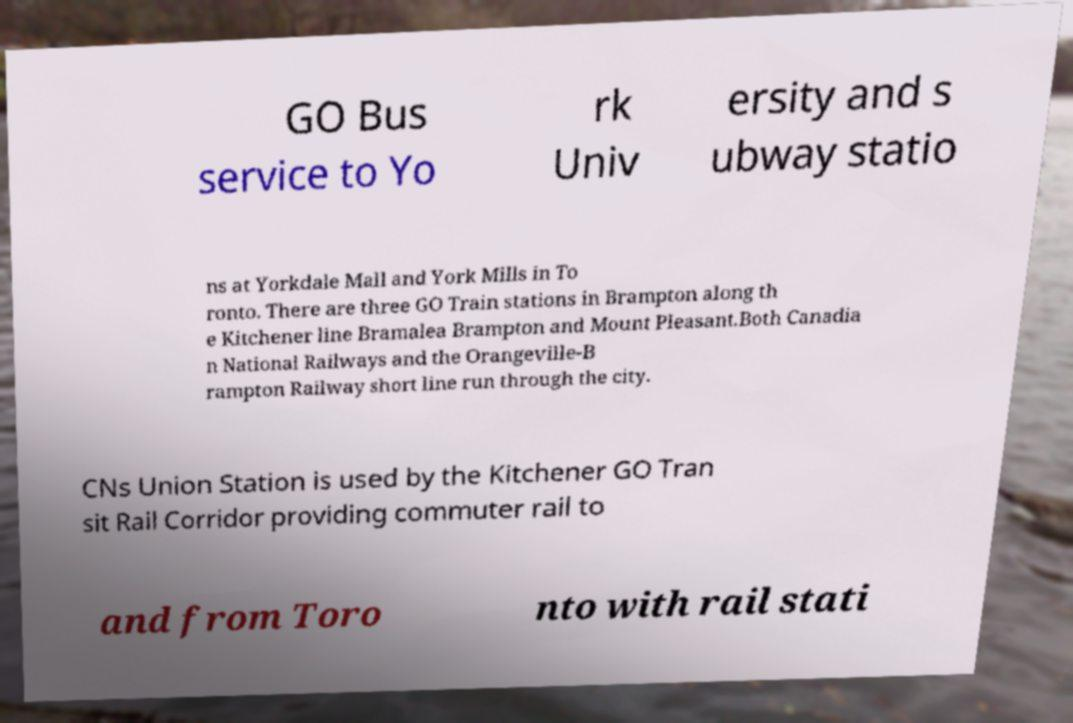Could you assist in decoding the text presented in this image and type it out clearly? GO Bus service to Yo rk Univ ersity and s ubway statio ns at Yorkdale Mall and York Mills in To ronto. There are three GO Train stations in Brampton along th e Kitchener line Bramalea Brampton and Mount Pleasant.Both Canadia n National Railways and the Orangeville-B rampton Railway short line run through the city. CNs Union Station is used by the Kitchener GO Tran sit Rail Corridor providing commuter rail to and from Toro nto with rail stati 